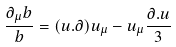<formula> <loc_0><loc_0><loc_500><loc_500>\frac { \partial _ { \mu } b } { b } = ( u . \partial ) u _ { \mu } - u _ { \mu } \frac { \partial . u } { 3 }</formula> 